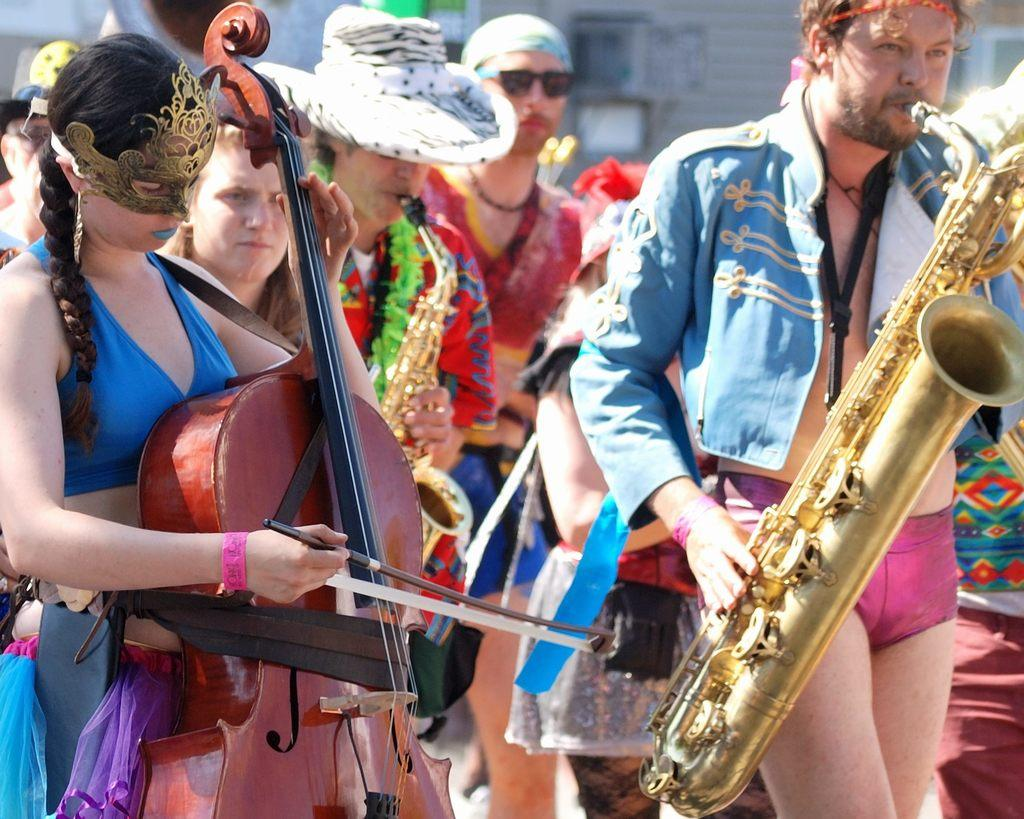What are the people in the image doing? The people in the image are holding musical instruments. Can you describe the attire of the people in the image? There is a woman wearing a mask and a man wearing a hat in the image. What is the position of the people in the image? All the people are standing. What type of beetle can be seen crawling on the man's hat in the image? There is no beetle present on the man's hat in the image. What color is the silver used to decorate the instruments in the image? There is no silver used to decorate the instruments in the image. 